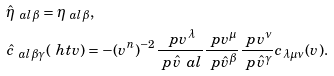<formula> <loc_0><loc_0><loc_500><loc_500>& \hat { \eta } _ { \ a l \beta } = \eta _ { \ a l \beta } , \\ & \hat { c } _ { \ a l \beta \gamma } ( \ h t v ) = - ( v ^ { n } ) ^ { - 2 } \frac { \ p v ^ { \lambda } } { \ p \hat { v } ^ { \ } a l } \frac { \ p v ^ { \mu } } { \ p \hat { v } ^ { \beta } } \frac { \ p v ^ { \nu } } { \ p \hat { v } ^ { \gamma } } c _ { \lambda \mu \nu } ( v ) .</formula> 